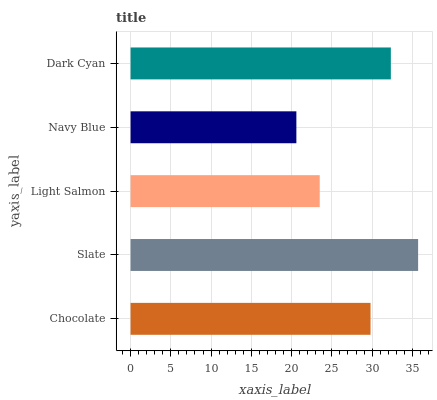Is Navy Blue the minimum?
Answer yes or no. Yes. Is Slate the maximum?
Answer yes or no. Yes. Is Light Salmon the minimum?
Answer yes or no. No. Is Light Salmon the maximum?
Answer yes or no. No. Is Slate greater than Light Salmon?
Answer yes or no. Yes. Is Light Salmon less than Slate?
Answer yes or no. Yes. Is Light Salmon greater than Slate?
Answer yes or no. No. Is Slate less than Light Salmon?
Answer yes or no. No. Is Chocolate the high median?
Answer yes or no. Yes. Is Chocolate the low median?
Answer yes or no. Yes. Is Slate the high median?
Answer yes or no. No. Is Navy Blue the low median?
Answer yes or no. No. 